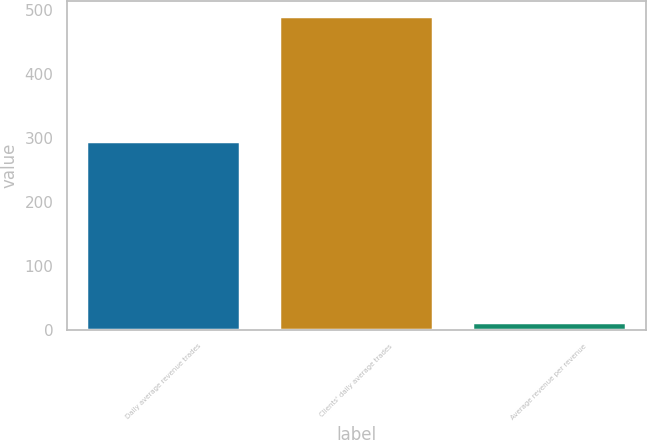<chart> <loc_0><loc_0><loc_500><loc_500><bar_chart><fcel>Daily average revenue trades<fcel>Clients' daily average trades<fcel>Average revenue per revenue<nl><fcel>295<fcel>490.5<fcel>12.31<nl></chart> 